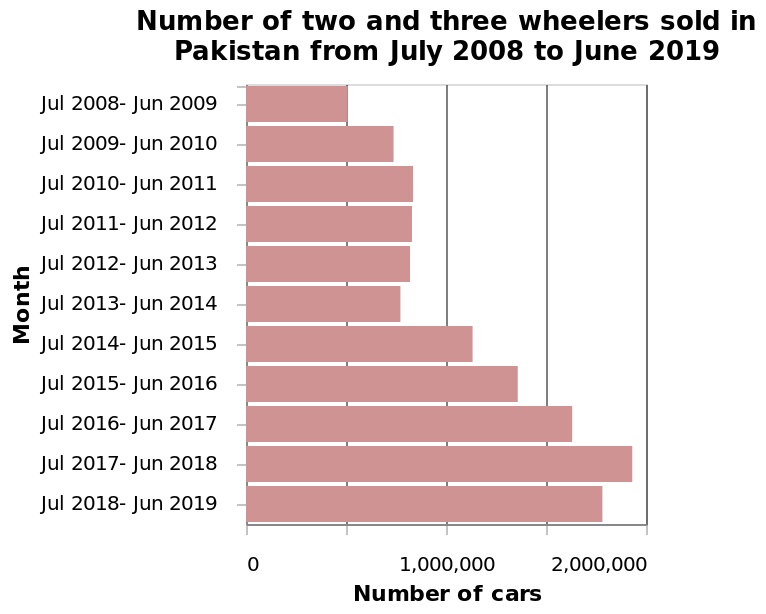<image>
What is represented on the y-axis of the bar chart?  The y-axis of the bar chart represents the months from July 2008 to June 2019. What is the title of the bar chart?  The title of the bar chart is "Number of two and three wheelers sold in Pakistan from July 2008 to June 2019." What time period does the bar chart cover? The bar chart covers the time period from July 2008 to June 2019. Is the title of the bar chart "Number of two and four wheelers sold in Pakistan from July 2008 to June 2019"? No. The title of the bar chart is "Number of two and three wheelers sold in Pakistan from July 2008 to June 2019." 